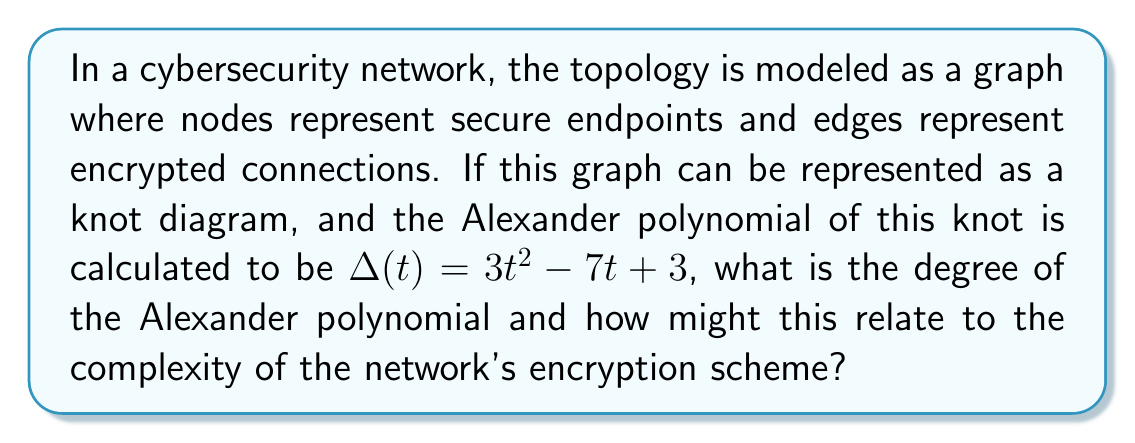Show me your answer to this math problem. To answer this question, let's break it down step-by-step:

1) First, we need to understand what the Alexander polynomial represents in knot theory:
   - The Alexander polynomial is a knot invariant, meaning it doesn't change under continuous deformations of the knot.
   - In the context of network topology, it can be seen as a measure of the complexity of the network's structure.

2) The given Alexander polynomial is $\Delta(t) = 3t^2 - 7t + 3$

3) To find the degree of this polynomial:
   - Look at the highest power of t in the polynomial
   - In this case, the highest power is 2

4) Therefore, the degree of the Alexander polynomial is 2.

5) Relating this to network complexity and encryption:
   - The degree of the Alexander polynomial often correlates with the complexity of the knot (or in this case, the network topology).
   - A higher degree generally indicates a more complex structure.
   - In cybersecurity, a more complex network topology can potentially support more sophisticated encryption schemes.
   - The degree 2 suggests a moderate level of complexity, which might indicate:
     a) A network with multiple interconnected nodes
     b) Potential for layered encryption protocols
     c) Opportunities for implementing advanced security measures like multi-factor authentication or nested VPNs

6) However, it's important to note that while the Alexander polynomial provides insights into the network's topological complexity, it doesn't directly determine the strength of the encryption. The actual encryption strength would depend on the specific algorithms and protocols used.
Answer: 2; moderate network complexity 